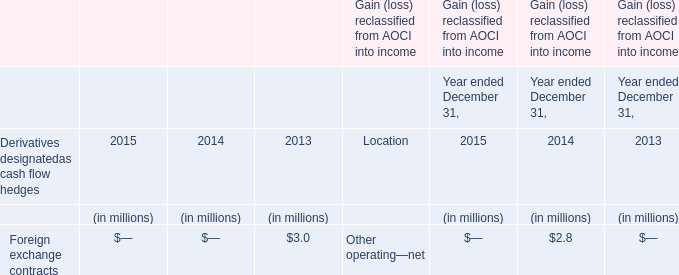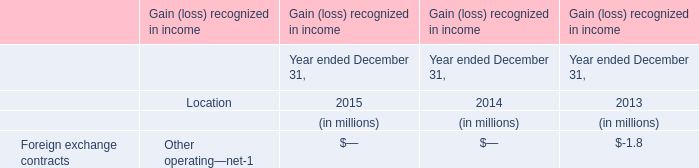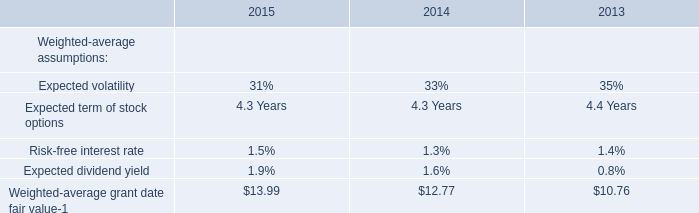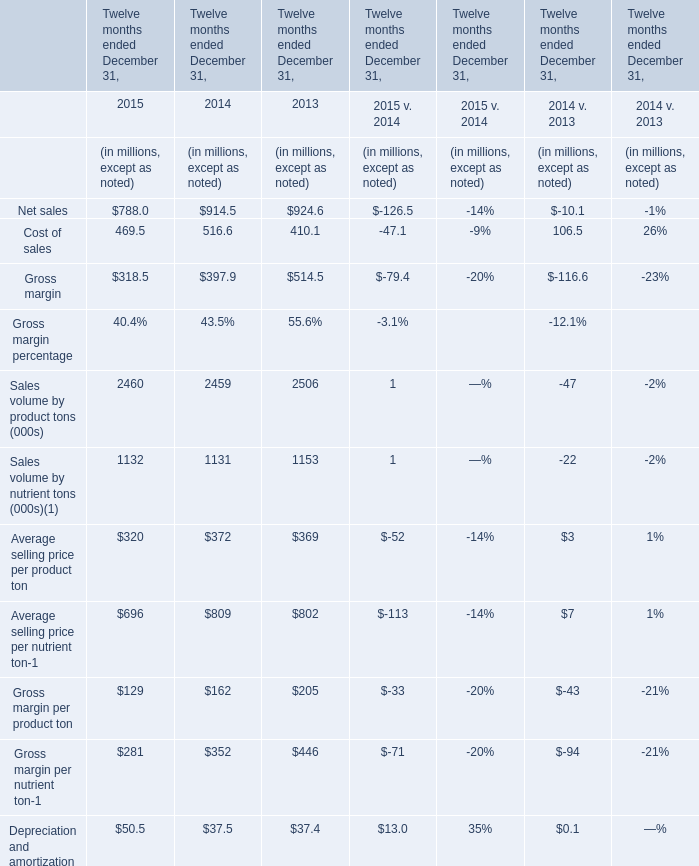In the year with lowest amount of Net sales, what's the increasing rate of Cost of sales? 
Computations: ((469.5 - 516.6) / 516.6)
Answer: -0.09117. 